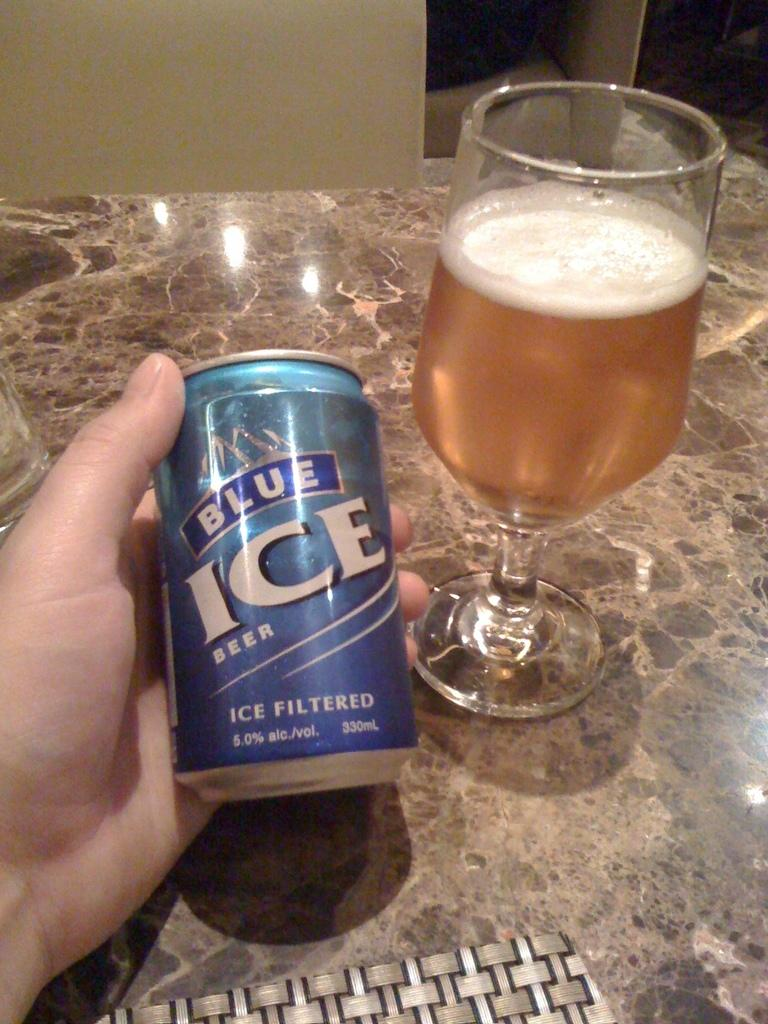<image>
Render a clear and concise summary of the photo. A person holding a can of Blue Ice Beer with a goblet of beer that is partially drank. 